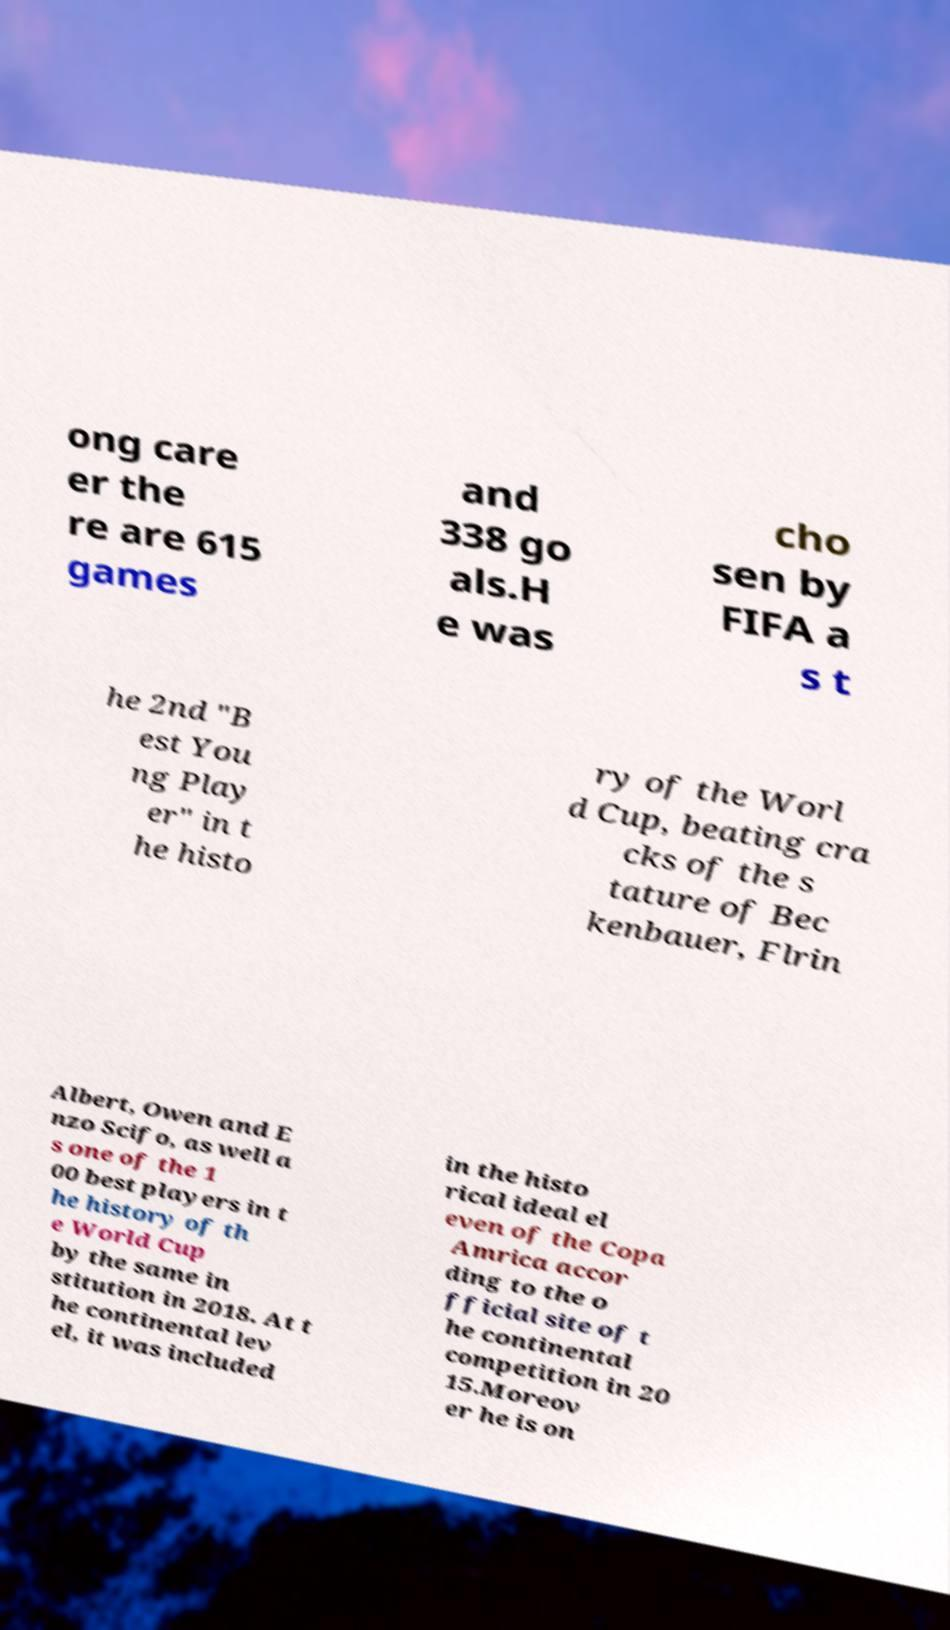Could you extract and type out the text from this image? ong care er the re are 615 games and 338 go als.H e was cho sen by FIFA a s t he 2nd "B est You ng Play er" in t he histo ry of the Worl d Cup, beating cra cks of the s tature of Bec kenbauer, Flrin Albert, Owen and E nzo Scifo, as well a s one of the 1 00 best players in t he history of th e World Cup by the same in stitution in 2018. At t he continental lev el, it was included in the histo rical ideal el even of the Copa Amrica accor ding to the o fficial site of t he continental competition in 20 15.Moreov er he is on 